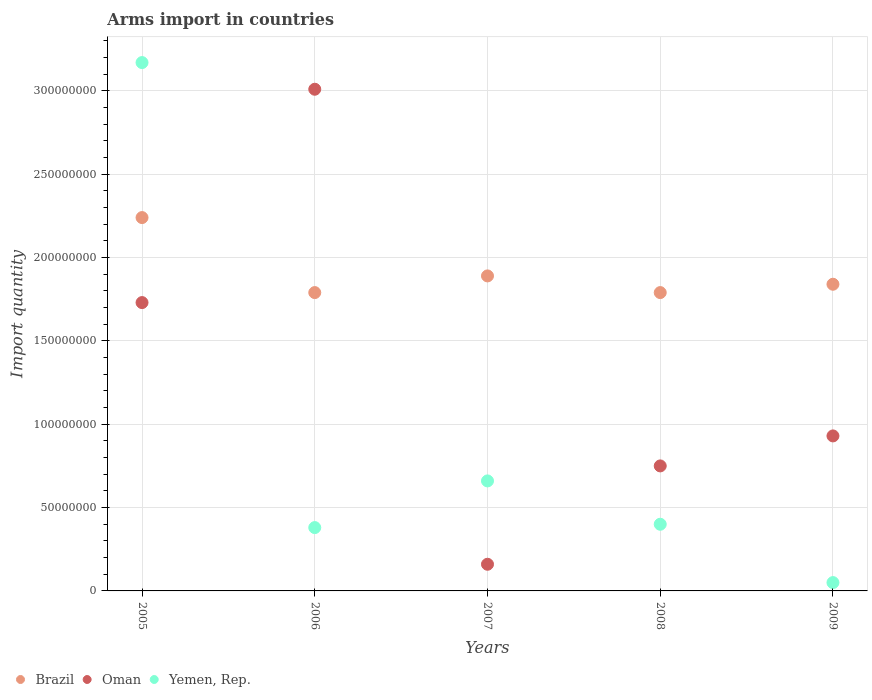Is the number of dotlines equal to the number of legend labels?
Provide a succinct answer. Yes. What is the total arms import in Brazil in 2008?
Provide a short and direct response. 1.79e+08. Across all years, what is the maximum total arms import in Yemen, Rep.?
Keep it short and to the point. 3.17e+08. Across all years, what is the minimum total arms import in Oman?
Keep it short and to the point. 1.60e+07. In which year was the total arms import in Brazil minimum?
Make the answer very short. 2006. What is the total total arms import in Oman in the graph?
Offer a terse response. 6.58e+08. What is the difference between the total arms import in Yemen, Rep. in 2007 and that in 2009?
Provide a short and direct response. 6.10e+07. What is the difference between the total arms import in Brazil in 2006 and the total arms import in Oman in 2007?
Ensure brevity in your answer.  1.63e+08. What is the average total arms import in Brazil per year?
Your answer should be compact. 1.91e+08. In the year 2007, what is the difference between the total arms import in Yemen, Rep. and total arms import in Brazil?
Make the answer very short. -1.23e+08. In how many years, is the total arms import in Yemen, Rep. greater than 320000000?
Your response must be concise. 0. What is the ratio of the total arms import in Brazil in 2007 to that in 2008?
Your response must be concise. 1.06. What is the difference between the highest and the second highest total arms import in Yemen, Rep.?
Make the answer very short. 2.51e+08. What is the difference between the highest and the lowest total arms import in Brazil?
Ensure brevity in your answer.  4.50e+07. In how many years, is the total arms import in Oman greater than the average total arms import in Oman taken over all years?
Offer a very short reply. 2. Is the sum of the total arms import in Yemen, Rep. in 2005 and 2006 greater than the maximum total arms import in Oman across all years?
Ensure brevity in your answer.  Yes. Does the total arms import in Brazil monotonically increase over the years?
Provide a succinct answer. No. How many years are there in the graph?
Make the answer very short. 5. Are the values on the major ticks of Y-axis written in scientific E-notation?
Give a very brief answer. No. Does the graph contain grids?
Make the answer very short. Yes. How many legend labels are there?
Keep it short and to the point. 3. What is the title of the graph?
Your response must be concise. Arms import in countries. Does "San Marino" appear as one of the legend labels in the graph?
Provide a short and direct response. No. What is the label or title of the X-axis?
Your answer should be very brief. Years. What is the label or title of the Y-axis?
Your response must be concise. Import quantity. What is the Import quantity in Brazil in 2005?
Make the answer very short. 2.24e+08. What is the Import quantity of Oman in 2005?
Offer a terse response. 1.73e+08. What is the Import quantity of Yemen, Rep. in 2005?
Keep it short and to the point. 3.17e+08. What is the Import quantity in Brazil in 2006?
Offer a terse response. 1.79e+08. What is the Import quantity of Oman in 2006?
Ensure brevity in your answer.  3.01e+08. What is the Import quantity in Yemen, Rep. in 2006?
Ensure brevity in your answer.  3.80e+07. What is the Import quantity in Brazil in 2007?
Make the answer very short. 1.89e+08. What is the Import quantity in Oman in 2007?
Your answer should be compact. 1.60e+07. What is the Import quantity of Yemen, Rep. in 2007?
Offer a terse response. 6.60e+07. What is the Import quantity in Brazil in 2008?
Your answer should be compact. 1.79e+08. What is the Import quantity in Oman in 2008?
Offer a very short reply. 7.50e+07. What is the Import quantity in Yemen, Rep. in 2008?
Your response must be concise. 4.00e+07. What is the Import quantity in Brazil in 2009?
Your answer should be very brief. 1.84e+08. What is the Import quantity in Oman in 2009?
Offer a terse response. 9.30e+07. Across all years, what is the maximum Import quantity of Brazil?
Provide a short and direct response. 2.24e+08. Across all years, what is the maximum Import quantity in Oman?
Give a very brief answer. 3.01e+08. Across all years, what is the maximum Import quantity of Yemen, Rep.?
Provide a succinct answer. 3.17e+08. Across all years, what is the minimum Import quantity in Brazil?
Your answer should be compact. 1.79e+08. Across all years, what is the minimum Import quantity in Oman?
Your response must be concise. 1.60e+07. Across all years, what is the minimum Import quantity in Yemen, Rep.?
Offer a very short reply. 5.00e+06. What is the total Import quantity of Brazil in the graph?
Your response must be concise. 9.55e+08. What is the total Import quantity of Oman in the graph?
Provide a succinct answer. 6.58e+08. What is the total Import quantity of Yemen, Rep. in the graph?
Give a very brief answer. 4.66e+08. What is the difference between the Import quantity of Brazil in 2005 and that in 2006?
Keep it short and to the point. 4.50e+07. What is the difference between the Import quantity of Oman in 2005 and that in 2006?
Keep it short and to the point. -1.28e+08. What is the difference between the Import quantity of Yemen, Rep. in 2005 and that in 2006?
Your response must be concise. 2.79e+08. What is the difference between the Import quantity of Brazil in 2005 and that in 2007?
Provide a succinct answer. 3.50e+07. What is the difference between the Import quantity in Oman in 2005 and that in 2007?
Your answer should be compact. 1.57e+08. What is the difference between the Import quantity of Yemen, Rep. in 2005 and that in 2007?
Provide a short and direct response. 2.51e+08. What is the difference between the Import quantity of Brazil in 2005 and that in 2008?
Your answer should be very brief. 4.50e+07. What is the difference between the Import quantity in Oman in 2005 and that in 2008?
Give a very brief answer. 9.80e+07. What is the difference between the Import quantity of Yemen, Rep. in 2005 and that in 2008?
Keep it short and to the point. 2.77e+08. What is the difference between the Import quantity of Brazil in 2005 and that in 2009?
Keep it short and to the point. 4.00e+07. What is the difference between the Import quantity in Oman in 2005 and that in 2009?
Make the answer very short. 8.00e+07. What is the difference between the Import quantity in Yemen, Rep. in 2005 and that in 2009?
Provide a short and direct response. 3.12e+08. What is the difference between the Import quantity of Brazil in 2006 and that in 2007?
Give a very brief answer. -1.00e+07. What is the difference between the Import quantity in Oman in 2006 and that in 2007?
Ensure brevity in your answer.  2.85e+08. What is the difference between the Import quantity of Yemen, Rep. in 2006 and that in 2007?
Offer a terse response. -2.80e+07. What is the difference between the Import quantity in Brazil in 2006 and that in 2008?
Make the answer very short. 0. What is the difference between the Import quantity of Oman in 2006 and that in 2008?
Your answer should be very brief. 2.26e+08. What is the difference between the Import quantity in Yemen, Rep. in 2006 and that in 2008?
Your response must be concise. -2.00e+06. What is the difference between the Import quantity in Brazil in 2006 and that in 2009?
Offer a terse response. -5.00e+06. What is the difference between the Import quantity of Oman in 2006 and that in 2009?
Offer a very short reply. 2.08e+08. What is the difference between the Import quantity in Yemen, Rep. in 2006 and that in 2009?
Provide a short and direct response. 3.30e+07. What is the difference between the Import quantity of Oman in 2007 and that in 2008?
Provide a succinct answer. -5.90e+07. What is the difference between the Import quantity in Yemen, Rep. in 2007 and that in 2008?
Your response must be concise. 2.60e+07. What is the difference between the Import quantity of Brazil in 2007 and that in 2009?
Offer a terse response. 5.00e+06. What is the difference between the Import quantity in Oman in 2007 and that in 2009?
Keep it short and to the point. -7.70e+07. What is the difference between the Import quantity in Yemen, Rep. in 2007 and that in 2009?
Your answer should be compact. 6.10e+07. What is the difference between the Import quantity of Brazil in 2008 and that in 2009?
Your answer should be compact. -5.00e+06. What is the difference between the Import quantity in Oman in 2008 and that in 2009?
Your answer should be compact. -1.80e+07. What is the difference between the Import quantity of Yemen, Rep. in 2008 and that in 2009?
Provide a succinct answer. 3.50e+07. What is the difference between the Import quantity of Brazil in 2005 and the Import quantity of Oman in 2006?
Offer a very short reply. -7.70e+07. What is the difference between the Import quantity in Brazil in 2005 and the Import quantity in Yemen, Rep. in 2006?
Give a very brief answer. 1.86e+08. What is the difference between the Import quantity in Oman in 2005 and the Import quantity in Yemen, Rep. in 2006?
Keep it short and to the point. 1.35e+08. What is the difference between the Import quantity of Brazil in 2005 and the Import quantity of Oman in 2007?
Your answer should be compact. 2.08e+08. What is the difference between the Import quantity of Brazil in 2005 and the Import quantity of Yemen, Rep. in 2007?
Your answer should be very brief. 1.58e+08. What is the difference between the Import quantity in Oman in 2005 and the Import quantity in Yemen, Rep. in 2007?
Offer a terse response. 1.07e+08. What is the difference between the Import quantity of Brazil in 2005 and the Import quantity of Oman in 2008?
Give a very brief answer. 1.49e+08. What is the difference between the Import quantity in Brazil in 2005 and the Import quantity in Yemen, Rep. in 2008?
Offer a terse response. 1.84e+08. What is the difference between the Import quantity of Oman in 2005 and the Import quantity of Yemen, Rep. in 2008?
Your response must be concise. 1.33e+08. What is the difference between the Import quantity of Brazil in 2005 and the Import quantity of Oman in 2009?
Provide a short and direct response. 1.31e+08. What is the difference between the Import quantity of Brazil in 2005 and the Import quantity of Yemen, Rep. in 2009?
Offer a terse response. 2.19e+08. What is the difference between the Import quantity in Oman in 2005 and the Import quantity in Yemen, Rep. in 2009?
Provide a short and direct response. 1.68e+08. What is the difference between the Import quantity of Brazil in 2006 and the Import quantity of Oman in 2007?
Ensure brevity in your answer.  1.63e+08. What is the difference between the Import quantity in Brazil in 2006 and the Import quantity in Yemen, Rep. in 2007?
Offer a very short reply. 1.13e+08. What is the difference between the Import quantity in Oman in 2006 and the Import quantity in Yemen, Rep. in 2007?
Your answer should be compact. 2.35e+08. What is the difference between the Import quantity in Brazil in 2006 and the Import quantity in Oman in 2008?
Offer a terse response. 1.04e+08. What is the difference between the Import quantity of Brazil in 2006 and the Import quantity of Yemen, Rep. in 2008?
Make the answer very short. 1.39e+08. What is the difference between the Import quantity in Oman in 2006 and the Import quantity in Yemen, Rep. in 2008?
Provide a succinct answer. 2.61e+08. What is the difference between the Import quantity in Brazil in 2006 and the Import quantity in Oman in 2009?
Provide a succinct answer. 8.60e+07. What is the difference between the Import quantity in Brazil in 2006 and the Import quantity in Yemen, Rep. in 2009?
Your answer should be very brief. 1.74e+08. What is the difference between the Import quantity in Oman in 2006 and the Import quantity in Yemen, Rep. in 2009?
Provide a succinct answer. 2.96e+08. What is the difference between the Import quantity of Brazil in 2007 and the Import quantity of Oman in 2008?
Keep it short and to the point. 1.14e+08. What is the difference between the Import quantity of Brazil in 2007 and the Import quantity of Yemen, Rep. in 2008?
Your answer should be very brief. 1.49e+08. What is the difference between the Import quantity of Oman in 2007 and the Import quantity of Yemen, Rep. in 2008?
Your answer should be very brief. -2.40e+07. What is the difference between the Import quantity in Brazil in 2007 and the Import quantity in Oman in 2009?
Provide a short and direct response. 9.60e+07. What is the difference between the Import quantity in Brazil in 2007 and the Import quantity in Yemen, Rep. in 2009?
Your answer should be very brief. 1.84e+08. What is the difference between the Import quantity of Oman in 2007 and the Import quantity of Yemen, Rep. in 2009?
Offer a terse response. 1.10e+07. What is the difference between the Import quantity in Brazil in 2008 and the Import quantity in Oman in 2009?
Your response must be concise. 8.60e+07. What is the difference between the Import quantity in Brazil in 2008 and the Import quantity in Yemen, Rep. in 2009?
Your answer should be compact. 1.74e+08. What is the difference between the Import quantity of Oman in 2008 and the Import quantity of Yemen, Rep. in 2009?
Your answer should be very brief. 7.00e+07. What is the average Import quantity of Brazil per year?
Your answer should be very brief. 1.91e+08. What is the average Import quantity of Oman per year?
Your response must be concise. 1.32e+08. What is the average Import quantity in Yemen, Rep. per year?
Your answer should be very brief. 9.32e+07. In the year 2005, what is the difference between the Import quantity of Brazil and Import quantity of Oman?
Offer a very short reply. 5.10e+07. In the year 2005, what is the difference between the Import quantity in Brazil and Import quantity in Yemen, Rep.?
Your answer should be very brief. -9.30e+07. In the year 2005, what is the difference between the Import quantity in Oman and Import quantity in Yemen, Rep.?
Provide a succinct answer. -1.44e+08. In the year 2006, what is the difference between the Import quantity of Brazil and Import quantity of Oman?
Offer a very short reply. -1.22e+08. In the year 2006, what is the difference between the Import quantity of Brazil and Import quantity of Yemen, Rep.?
Ensure brevity in your answer.  1.41e+08. In the year 2006, what is the difference between the Import quantity in Oman and Import quantity in Yemen, Rep.?
Keep it short and to the point. 2.63e+08. In the year 2007, what is the difference between the Import quantity in Brazil and Import quantity in Oman?
Give a very brief answer. 1.73e+08. In the year 2007, what is the difference between the Import quantity of Brazil and Import quantity of Yemen, Rep.?
Your answer should be very brief. 1.23e+08. In the year 2007, what is the difference between the Import quantity of Oman and Import quantity of Yemen, Rep.?
Give a very brief answer. -5.00e+07. In the year 2008, what is the difference between the Import quantity in Brazil and Import quantity in Oman?
Offer a terse response. 1.04e+08. In the year 2008, what is the difference between the Import quantity in Brazil and Import quantity in Yemen, Rep.?
Ensure brevity in your answer.  1.39e+08. In the year 2008, what is the difference between the Import quantity of Oman and Import quantity of Yemen, Rep.?
Your answer should be compact. 3.50e+07. In the year 2009, what is the difference between the Import quantity of Brazil and Import quantity of Oman?
Ensure brevity in your answer.  9.10e+07. In the year 2009, what is the difference between the Import quantity of Brazil and Import quantity of Yemen, Rep.?
Offer a terse response. 1.79e+08. In the year 2009, what is the difference between the Import quantity in Oman and Import quantity in Yemen, Rep.?
Keep it short and to the point. 8.80e+07. What is the ratio of the Import quantity of Brazil in 2005 to that in 2006?
Keep it short and to the point. 1.25. What is the ratio of the Import quantity in Oman in 2005 to that in 2006?
Ensure brevity in your answer.  0.57. What is the ratio of the Import quantity in Yemen, Rep. in 2005 to that in 2006?
Your response must be concise. 8.34. What is the ratio of the Import quantity in Brazil in 2005 to that in 2007?
Your answer should be compact. 1.19. What is the ratio of the Import quantity of Oman in 2005 to that in 2007?
Your answer should be compact. 10.81. What is the ratio of the Import quantity of Yemen, Rep. in 2005 to that in 2007?
Offer a terse response. 4.8. What is the ratio of the Import quantity in Brazil in 2005 to that in 2008?
Your answer should be compact. 1.25. What is the ratio of the Import quantity in Oman in 2005 to that in 2008?
Offer a very short reply. 2.31. What is the ratio of the Import quantity in Yemen, Rep. in 2005 to that in 2008?
Your response must be concise. 7.92. What is the ratio of the Import quantity in Brazil in 2005 to that in 2009?
Your answer should be compact. 1.22. What is the ratio of the Import quantity in Oman in 2005 to that in 2009?
Keep it short and to the point. 1.86. What is the ratio of the Import quantity in Yemen, Rep. in 2005 to that in 2009?
Ensure brevity in your answer.  63.4. What is the ratio of the Import quantity of Brazil in 2006 to that in 2007?
Your answer should be very brief. 0.95. What is the ratio of the Import quantity in Oman in 2006 to that in 2007?
Ensure brevity in your answer.  18.81. What is the ratio of the Import quantity of Yemen, Rep. in 2006 to that in 2007?
Offer a very short reply. 0.58. What is the ratio of the Import quantity in Brazil in 2006 to that in 2008?
Give a very brief answer. 1. What is the ratio of the Import quantity of Oman in 2006 to that in 2008?
Make the answer very short. 4.01. What is the ratio of the Import quantity of Brazil in 2006 to that in 2009?
Offer a very short reply. 0.97. What is the ratio of the Import quantity in Oman in 2006 to that in 2009?
Offer a terse response. 3.24. What is the ratio of the Import quantity in Brazil in 2007 to that in 2008?
Your response must be concise. 1.06. What is the ratio of the Import quantity of Oman in 2007 to that in 2008?
Your answer should be very brief. 0.21. What is the ratio of the Import quantity in Yemen, Rep. in 2007 to that in 2008?
Ensure brevity in your answer.  1.65. What is the ratio of the Import quantity in Brazil in 2007 to that in 2009?
Your answer should be very brief. 1.03. What is the ratio of the Import quantity in Oman in 2007 to that in 2009?
Offer a very short reply. 0.17. What is the ratio of the Import quantity of Brazil in 2008 to that in 2009?
Offer a very short reply. 0.97. What is the ratio of the Import quantity of Oman in 2008 to that in 2009?
Give a very brief answer. 0.81. What is the difference between the highest and the second highest Import quantity of Brazil?
Ensure brevity in your answer.  3.50e+07. What is the difference between the highest and the second highest Import quantity in Oman?
Ensure brevity in your answer.  1.28e+08. What is the difference between the highest and the second highest Import quantity in Yemen, Rep.?
Your response must be concise. 2.51e+08. What is the difference between the highest and the lowest Import quantity in Brazil?
Keep it short and to the point. 4.50e+07. What is the difference between the highest and the lowest Import quantity in Oman?
Your answer should be very brief. 2.85e+08. What is the difference between the highest and the lowest Import quantity of Yemen, Rep.?
Make the answer very short. 3.12e+08. 